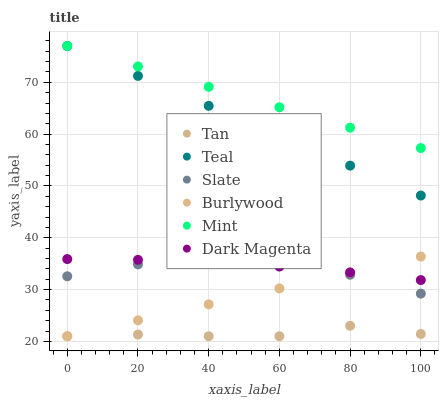Does Tan have the minimum area under the curve?
Answer yes or no. Yes. Does Mint have the maximum area under the curve?
Answer yes or no. Yes. Does Burlywood have the minimum area under the curve?
Answer yes or no. No. Does Burlywood have the maximum area under the curve?
Answer yes or no. No. Is Burlywood the smoothest?
Answer yes or no. Yes. Is Tan the roughest?
Answer yes or no. Yes. Is Slate the smoothest?
Answer yes or no. No. Is Slate the roughest?
Answer yes or no. No. Does Burlywood have the lowest value?
Answer yes or no. Yes. Does Slate have the lowest value?
Answer yes or no. No. Does Mint have the highest value?
Answer yes or no. Yes. Does Burlywood have the highest value?
Answer yes or no. No. Is Dark Magenta less than Teal?
Answer yes or no. Yes. Is Mint greater than Burlywood?
Answer yes or no. Yes. Does Burlywood intersect Dark Magenta?
Answer yes or no. Yes. Is Burlywood less than Dark Magenta?
Answer yes or no. No. Is Burlywood greater than Dark Magenta?
Answer yes or no. No. Does Dark Magenta intersect Teal?
Answer yes or no. No. 